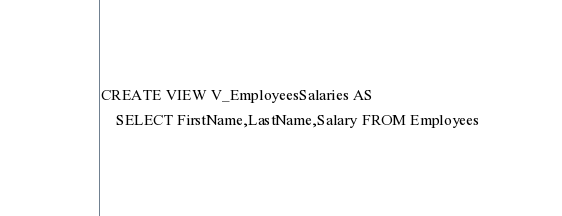<code> <loc_0><loc_0><loc_500><loc_500><_SQL_>CREATE VIEW V_EmployeesSalaries AS
	SELECT FirstName,LastName,Salary FROM Employees</code> 